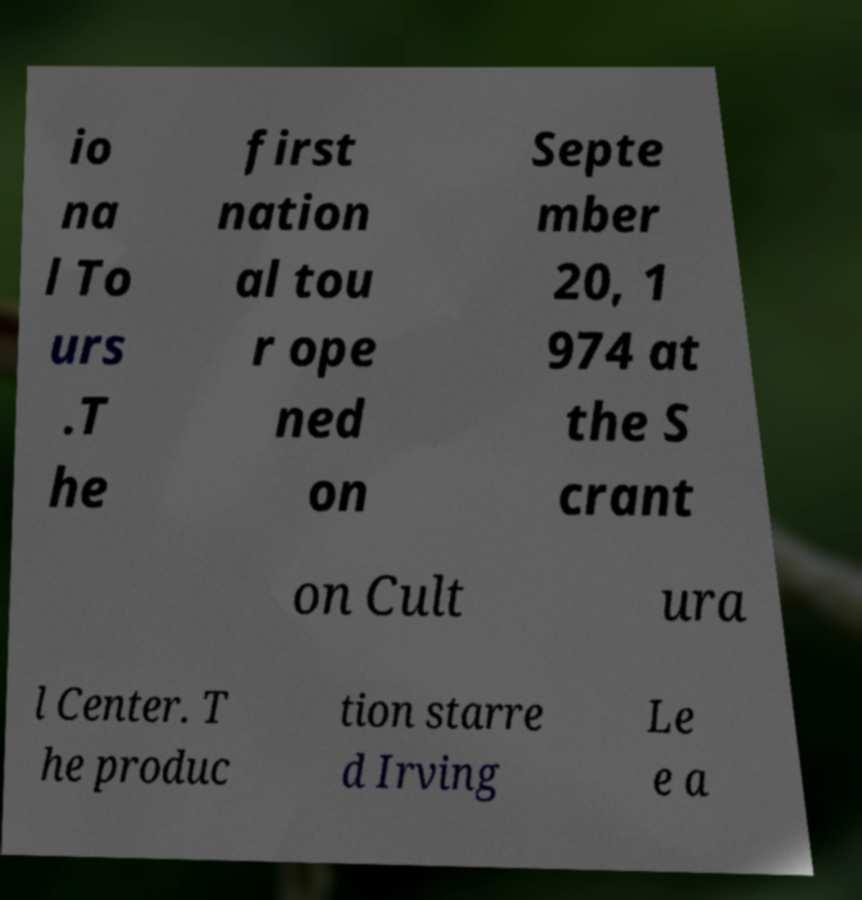Could you assist in decoding the text presented in this image and type it out clearly? io na l To urs .T he first nation al tou r ope ned on Septe mber 20, 1 974 at the S crant on Cult ura l Center. T he produc tion starre d Irving Le e a 